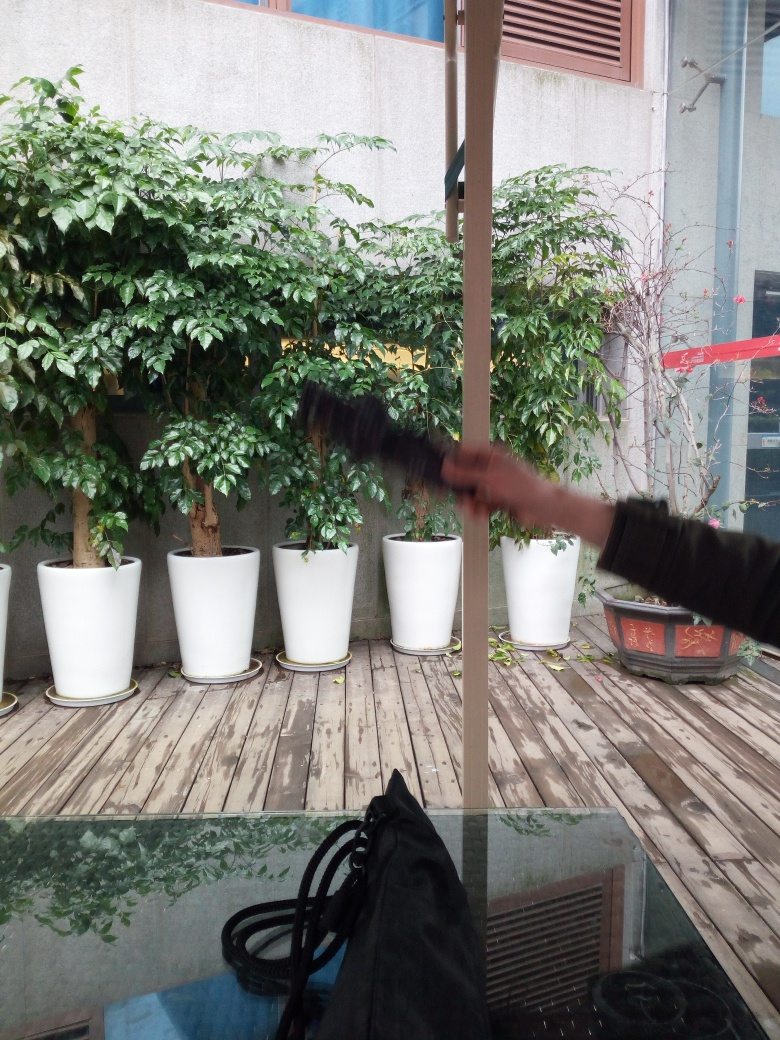Is this a public or private space? This space has characteristics of a semi-private area, such as a communal patio or garden within a corporate building or residential complex, indicated by the orderly placement of pots and the building's windows in close proximity. Is it well-maintained? It seems to be well-maintained, with the healthy looking plants in clean, uniform pots and the wooden floor appearing free of debris, except for a few fallen leaves, which may be recent. 